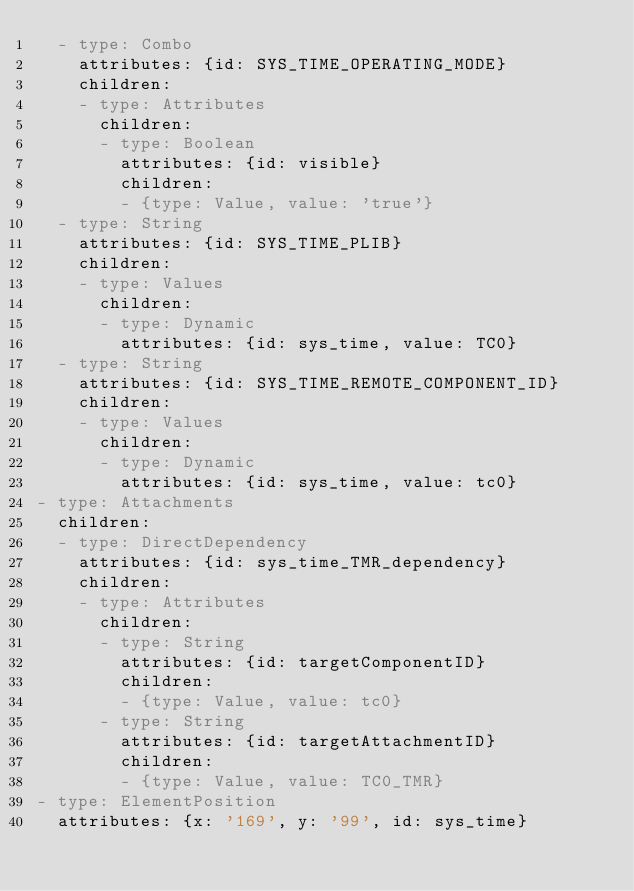<code> <loc_0><loc_0><loc_500><loc_500><_YAML_>  - type: Combo
    attributes: {id: SYS_TIME_OPERATING_MODE}
    children:
    - type: Attributes
      children:
      - type: Boolean
        attributes: {id: visible}
        children:
        - {type: Value, value: 'true'}
  - type: String
    attributes: {id: SYS_TIME_PLIB}
    children:
    - type: Values
      children:
      - type: Dynamic
        attributes: {id: sys_time, value: TC0}
  - type: String
    attributes: {id: SYS_TIME_REMOTE_COMPONENT_ID}
    children:
    - type: Values
      children:
      - type: Dynamic
        attributes: {id: sys_time, value: tc0}
- type: Attachments
  children:
  - type: DirectDependency
    attributes: {id: sys_time_TMR_dependency}
    children:
    - type: Attributes
      children:
      - type: String
        attributes: {id: targetComponentID}
        children:
        - {type: Value, value: tc0}
      - type: String
        attributes: {id: targetAttachmentID}
        children:
        - {type: Value, value: TC0_TMR}
- type: ElementPosition
  attributes: {x: '169', y: '99', id: sys_time}
</code> 